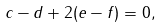Convert formula to latex. <formula><loc_0><loc_0><loc_500><loc_500>c - d + 2 ( e - f ) = 0 ,</formula> 